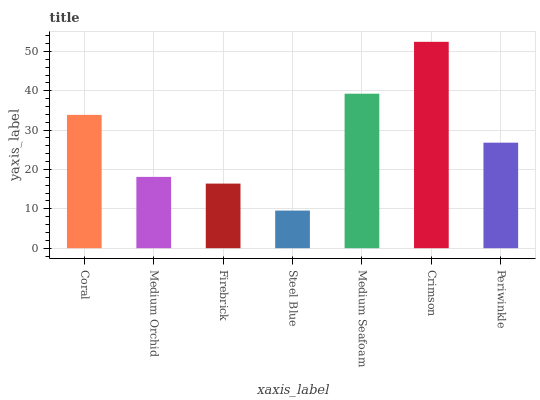Is Steel Blue the minimum?
Answer yes or no. Yes. Is Crimson the maximum?
Answer yes or no. Yes. Is Medium Orchid the minimum?
Answer yes or no. No. Is Medium Orchid the maximum?
Answer yes or no. No. Is Coral greater than Medium Orchid?
Answer yes or no. Yes. Is Medium Orchid less than Coral?
Answer yes or no. Yes. Is Medium Orchid greater than Coral?
Answer yes or no. No. Is Coral less than Medium Orchid?
Answer yes or no. No. Is Periwinkle the high median?
Answer yes or no. Yes. Is Periwinkle the low median?
Answer yes or no. Yes. Is Steel Blue the high median?
Answer yes or no. No. Is Medium Orchid the low median?
Answer yes or no. No. 